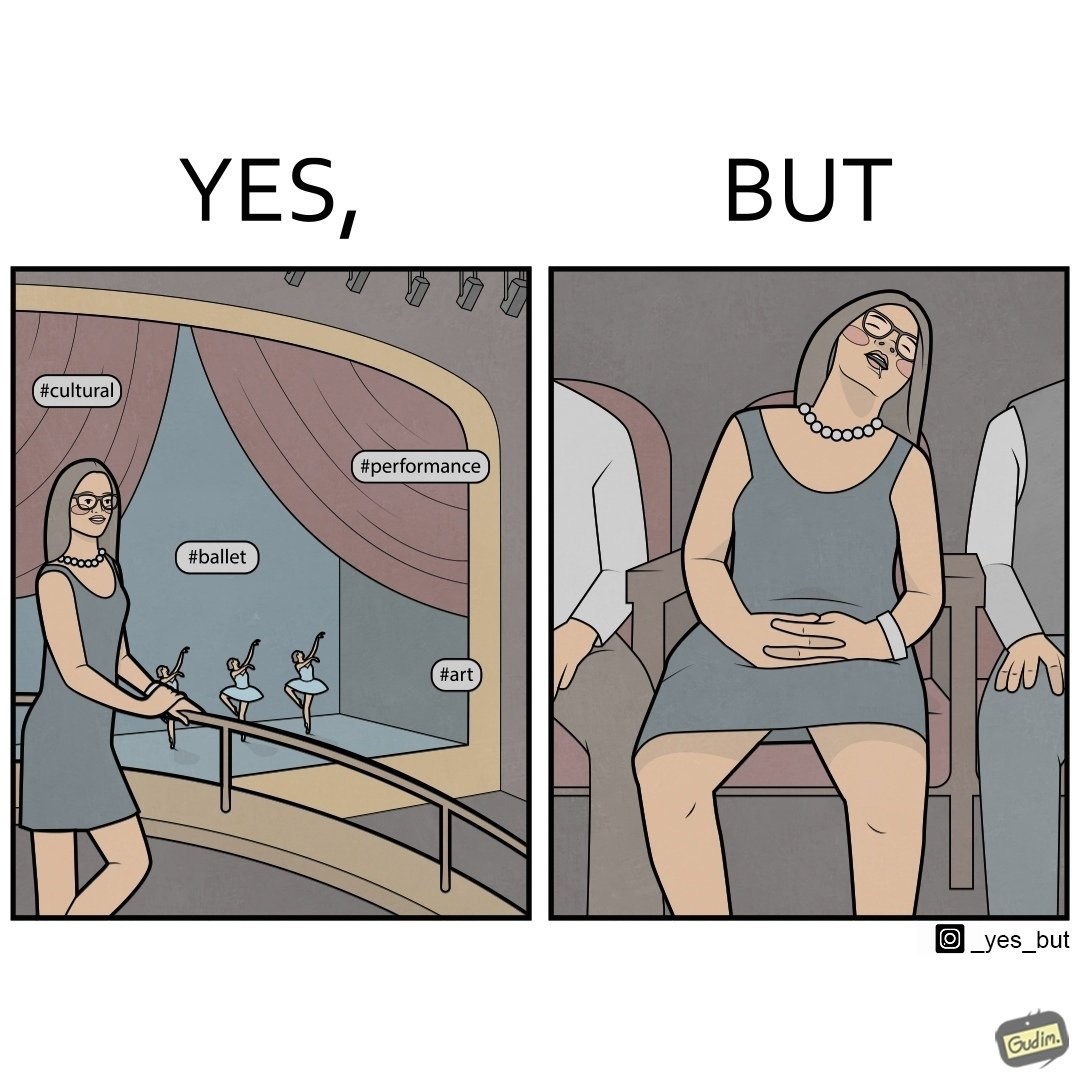Compare the left and right sides of this image. In the left part of the image: a woman standing with some pose for photo at any auditorium with some program going on in her background at the stage with some hashtags written on the image at different places In the right part of the image: a woman sitting on a chair and sleeping with her mouth open 